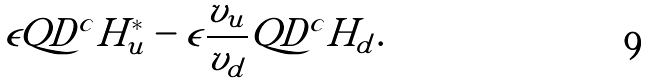Convert formula to latex. <formula><loc_0><loc_0><loc_500><loc_500>\epsilon Q D ^ { c } H _ { u } ^ { * } - \epsilon \frac { v _ { u } } { v _ { d } } Q D ^ { c } H _ { d } .</formula> 